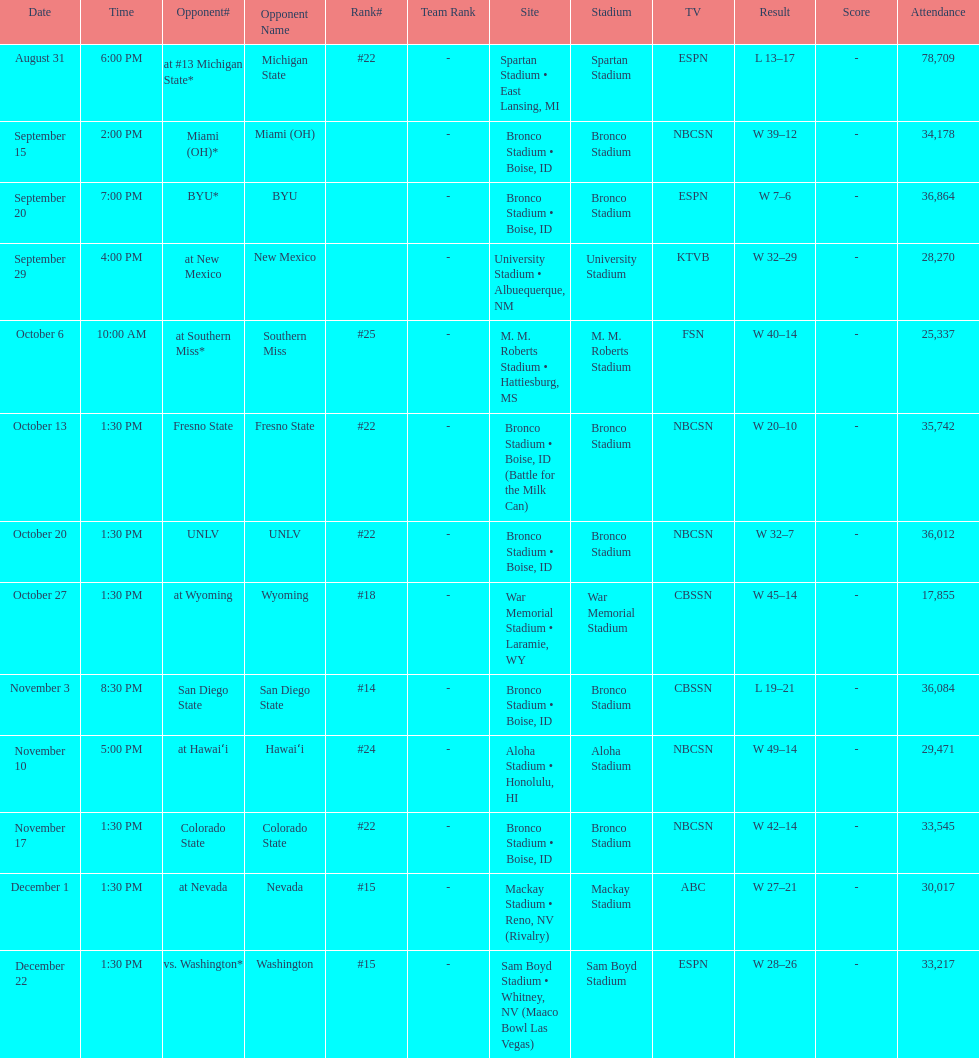Did the broncos on september 29th win by less than 5 points? Yes. 